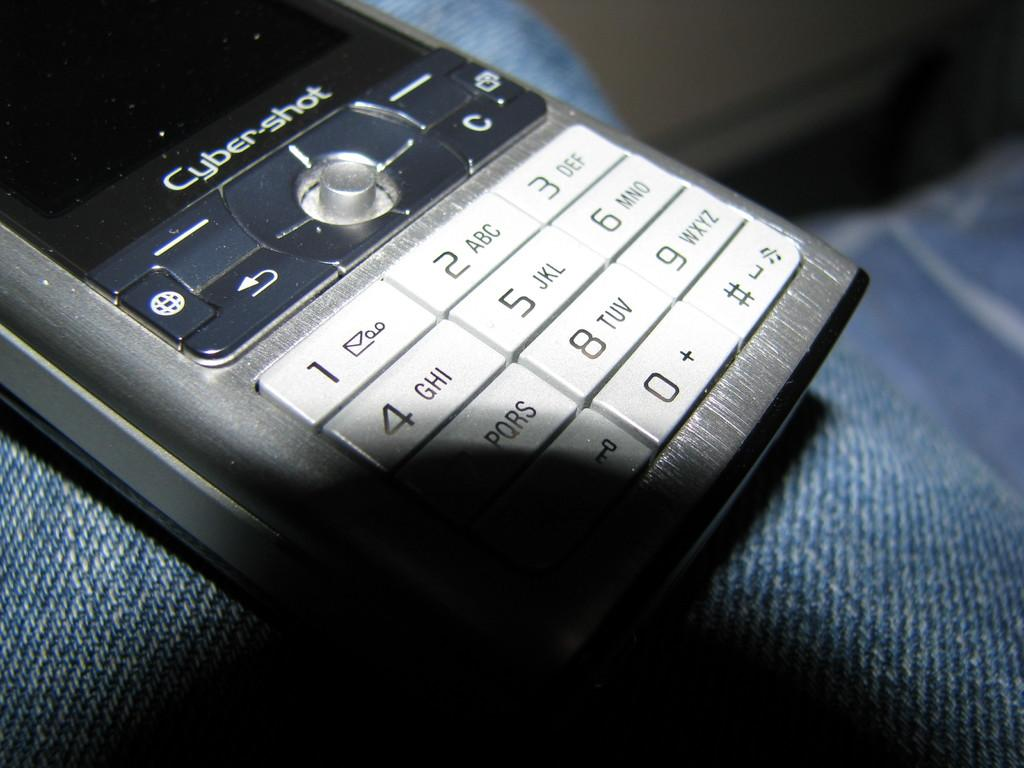Provide a one-sentence caption for the provided image. A Cyber Shot phone sits on top of a pair of denim. 